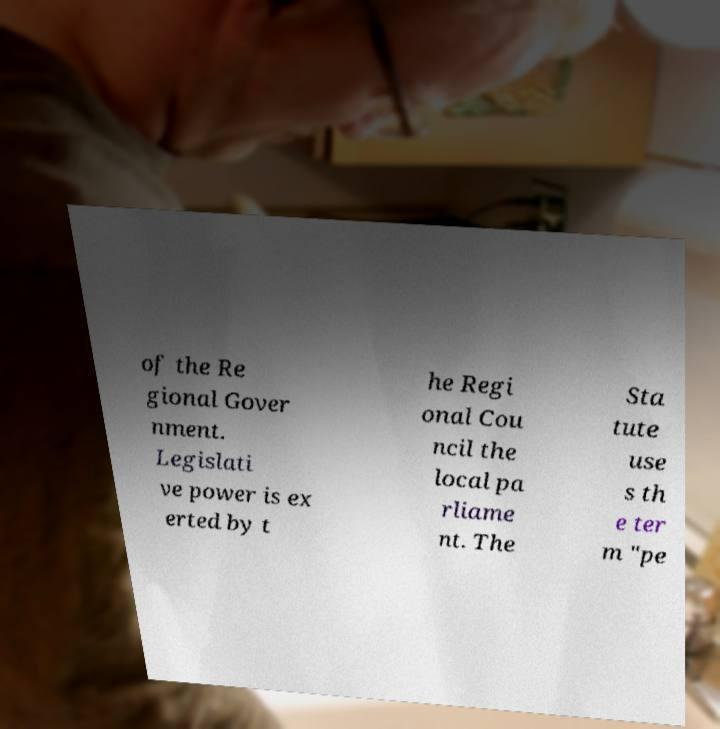Could you extract and type out the text from this image? of the Re gional Gover nment. Legislati ve power is ex erted by t he Regi onal Cou ncil the local pa rliame nt. The Sta tute use s th e ter m "pe 